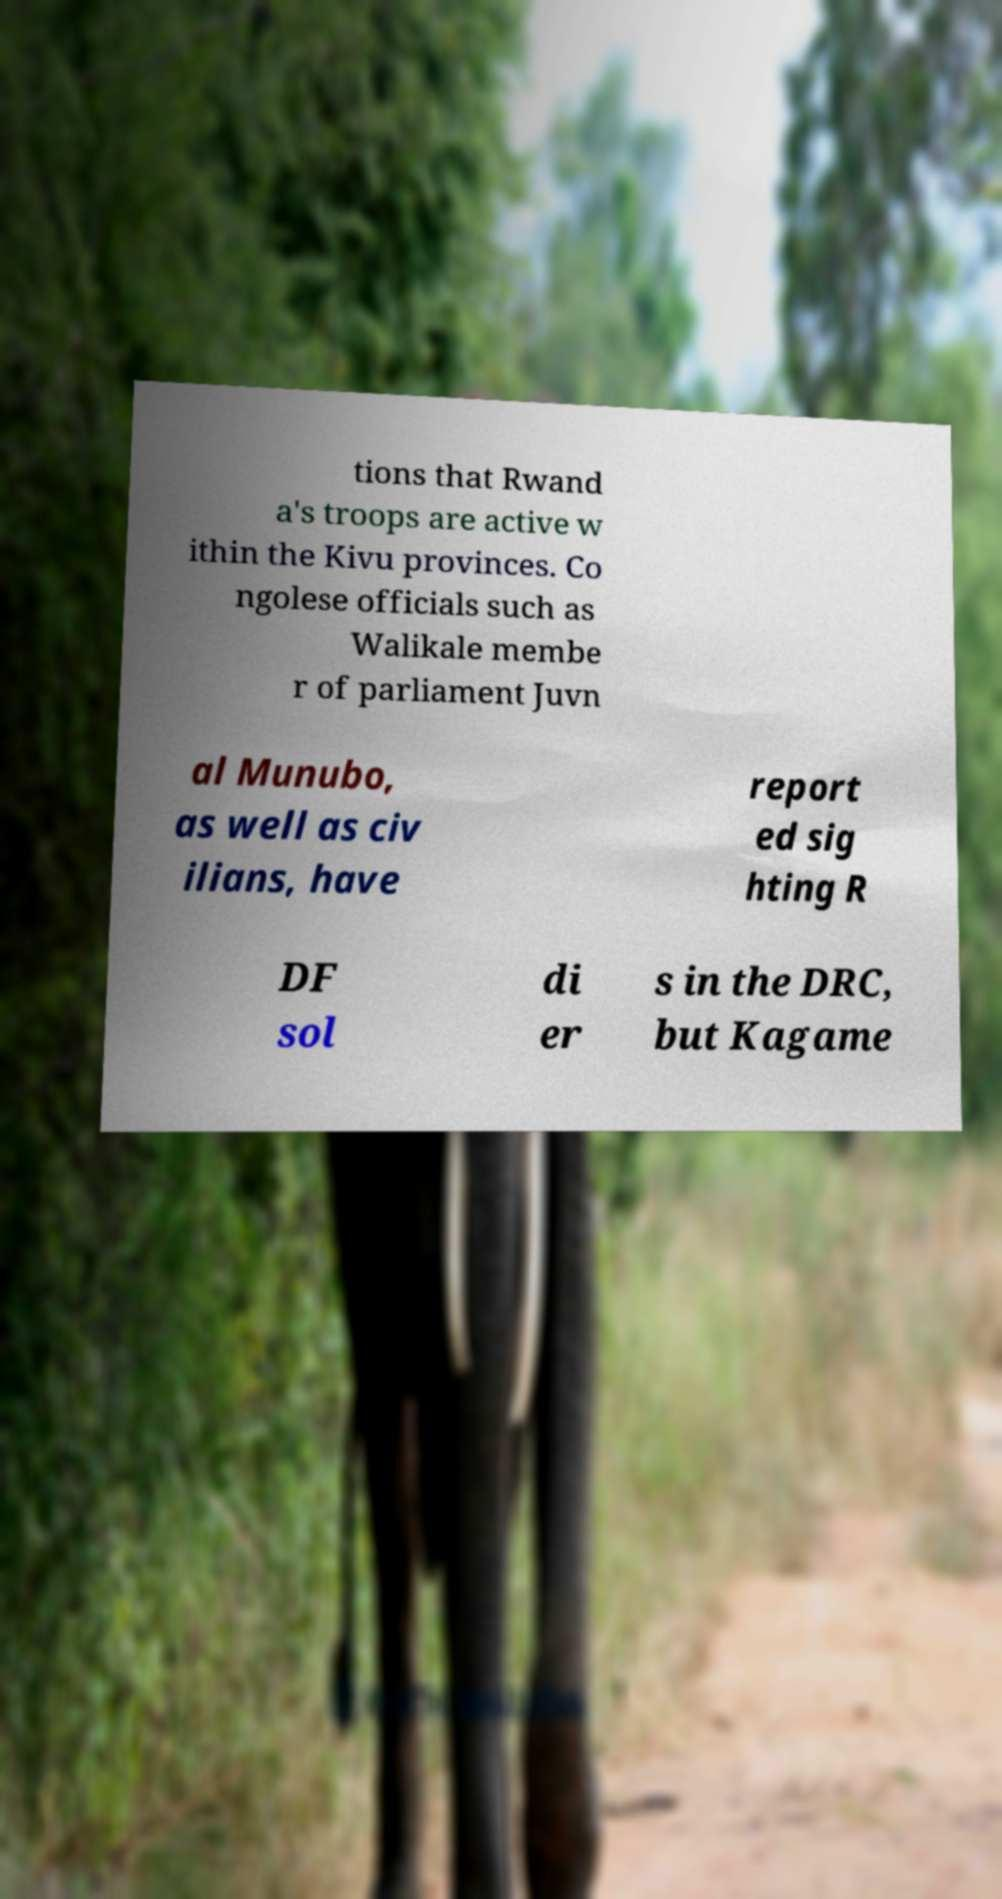Could you assist in decoding the text presented in this image and type it out clearly? tions that Rwand a's troops are active w ithin the Kivu provinces. Co ngolese officials such as Walikale membe r of parliament Juvn al Munubo, as well as civ ilians, have report ed sig hting R DF sol di er s in the DRC, but Kagame 